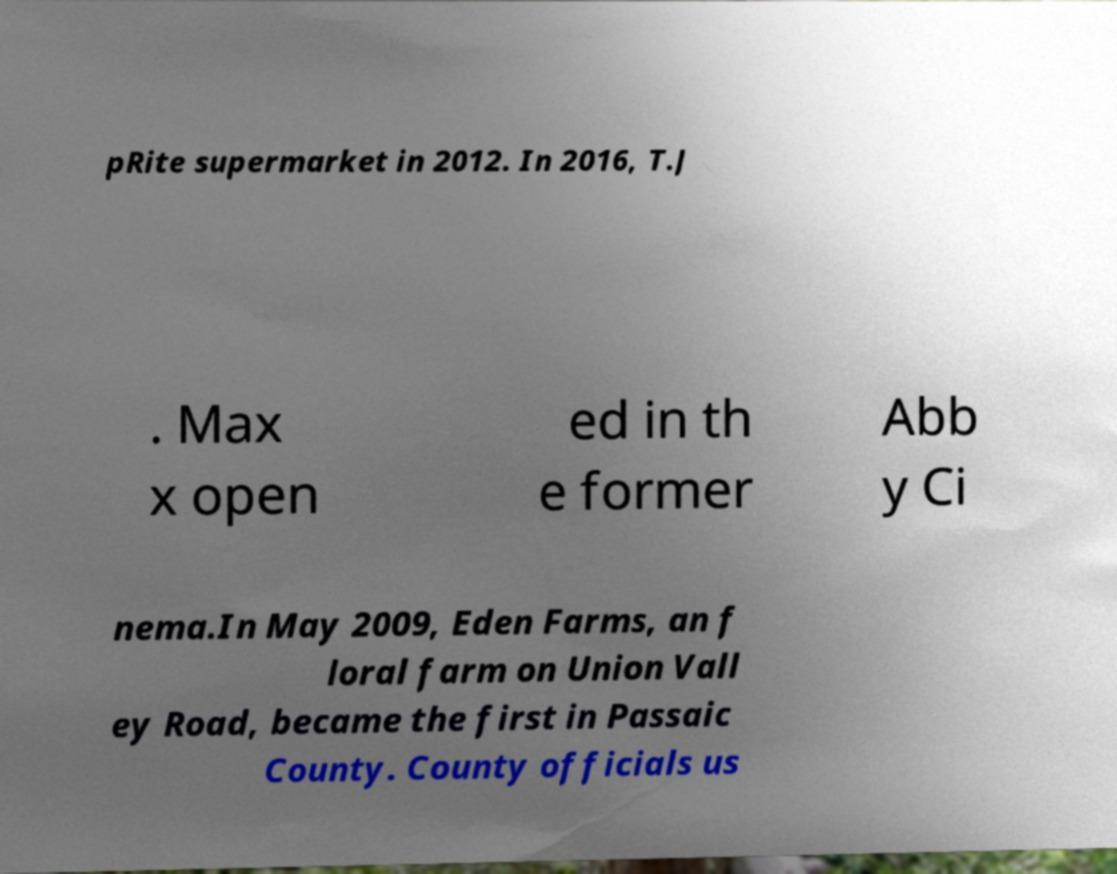Could you assist in decoding the text presented in this image and type it out clearly? pRite supermarket in 2012. In 2016, T.J . Max x open ed in th e former Abb y Ci nema.In May 2009, Eden Farms, an f loral farm on Union Vall ey Road, became the first in Passaic County. County officials us 